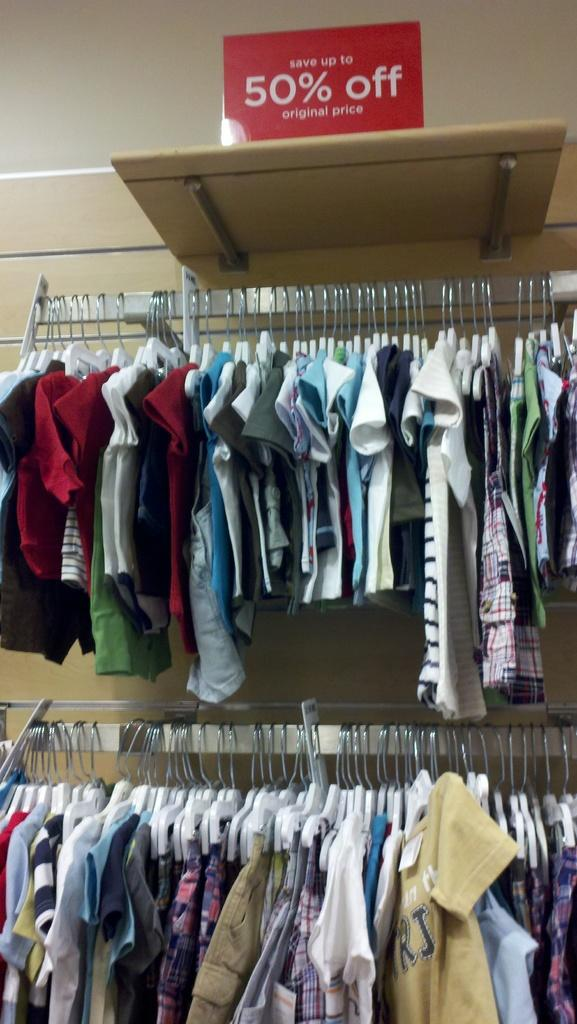<image>
Provide a brief description of the given image. Shirts on a rack are on sale for 50% off. 